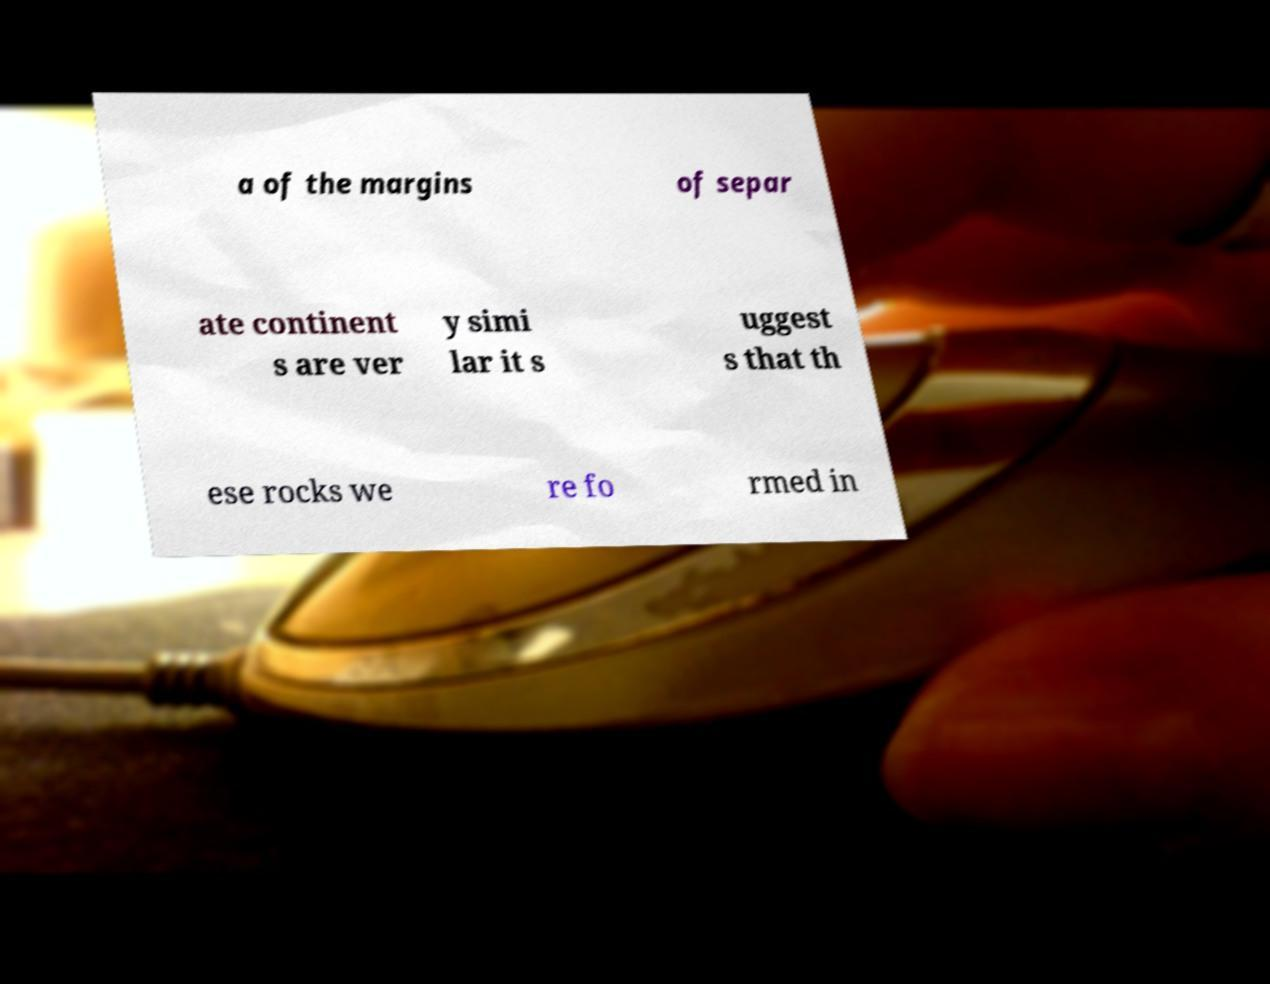There's text embedded in this image that I need extracted. Can you transcribe it verbatim? a of the margins of separ ate continent s are ver y simi lar it s uggest s that th ese rocks we re fo rmed in 